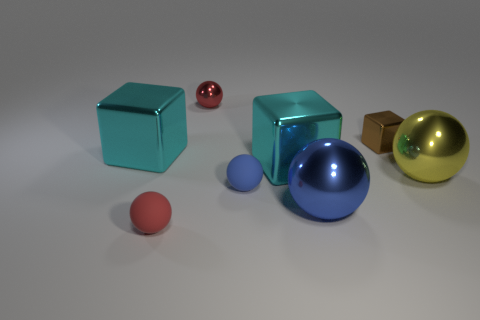Do the tiny thing that is in front of the large blue thing and the tiny blue ball have the same material?
Provide a short and direct response. Yes. Are there any other things that are the same size as the yellow shiny thing?
Give a very brief answer. Yes. Are there any brown metal blocks behind the tiny red metal sphere?
Your response must be concise. No. What is the color of the rubber ball that is behind the red ball left of the shiny thing behind the brown cube?
Keep it short and to the point. Blue. The blue thing that is the same size as the yellow sphere is what shape?
Offer a very short reply. Sphere. Are there more tiny metal spheres than large cyan metal things?
Your answer should be compact. No. Are there any large cyan metal cubes on the right side of the tiny rubber ball that is right of the red shiny thing?
Make the answer very short. Yes. The other small matte thing that is the same shape as the tiny blue thing is what color?
Ensure brevity in your answer.  Red. Are there any other things that are the same shape as the big blue thing?
Keep it short and to the point. Yes. There is a small ball that is the same material as the big blue sphere; what color is it?
Your answer should be very brief. Red. 